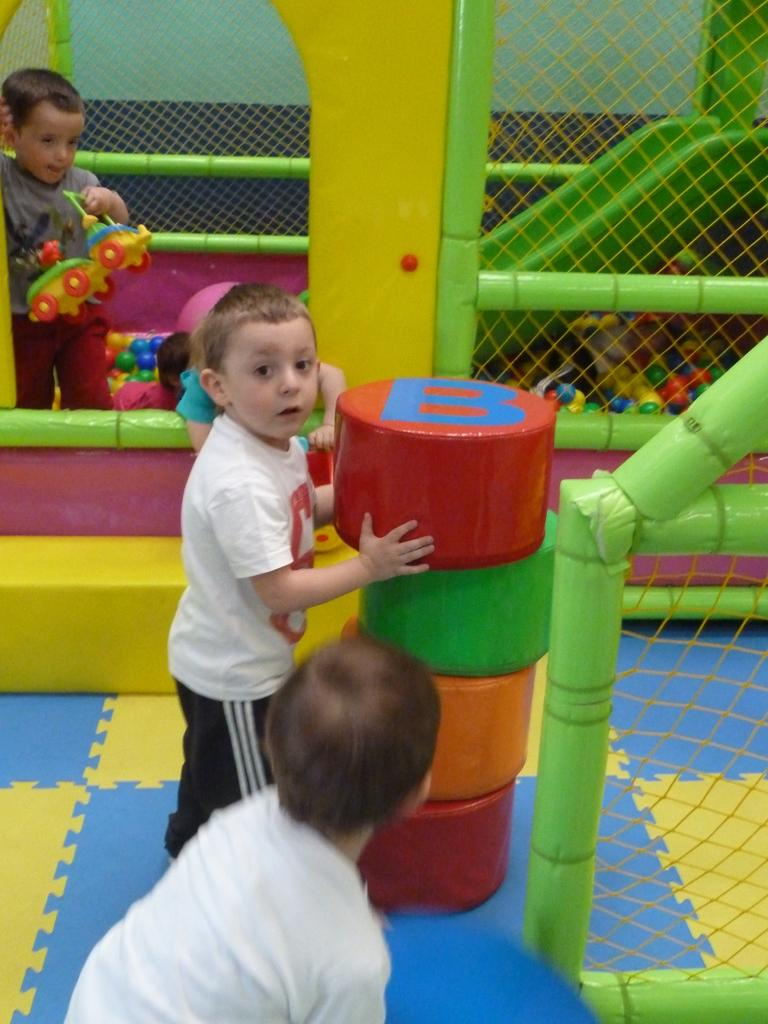What objects are in the center of the image? There are blocks in the center of the image. What are the children in the image doing? The children are playing in the image. What type of playground equipment can be seen on the right side of the image? There is a slide on the right side of the image. What type of toys are visible in the image? Balls are visible in the image. What is used to catch or contain the balls in the image? There is a net in the image. What can be seen in the background of the image? There is a wall in the background of the image. What type of quilt is being used as a cover for the slide in the image? There is no quilt present in the image, and the slide is not covered. What type of oil can be seen dripping from the balls in the image? There is no oil present in the image, and the balls are not dripping any substance. 